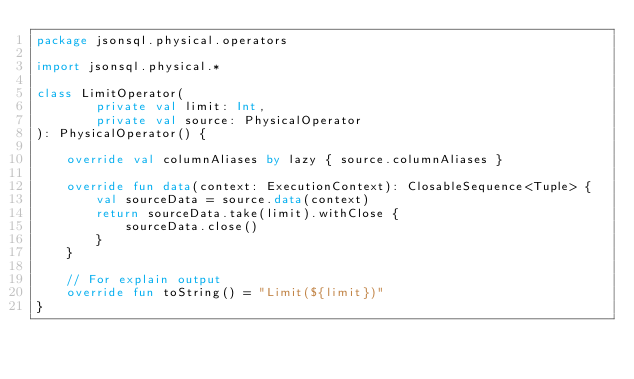Convert code to text. <code><loc_0><loc_0><loc_500><loc_500><_Kotlin_>package jsonsql.physical.operators

import jsonsql.physical.*

class LimitOperator(
        private val limit: Int,
        private val source: PhysicalOperator
): PhysicalOperator() {

    override val columnAliases by lazy { source.columnAliases }

    override fun data(context: ExecutionContext): ClosableSequence<Tuple> {
        val sourceData = source.data(context)
        return sourceData.take(limit).withClose {
            sourceData.close()
        }
    }

    // For explain output
    override fun toString() = "Limit(${limit})"
}</code> 